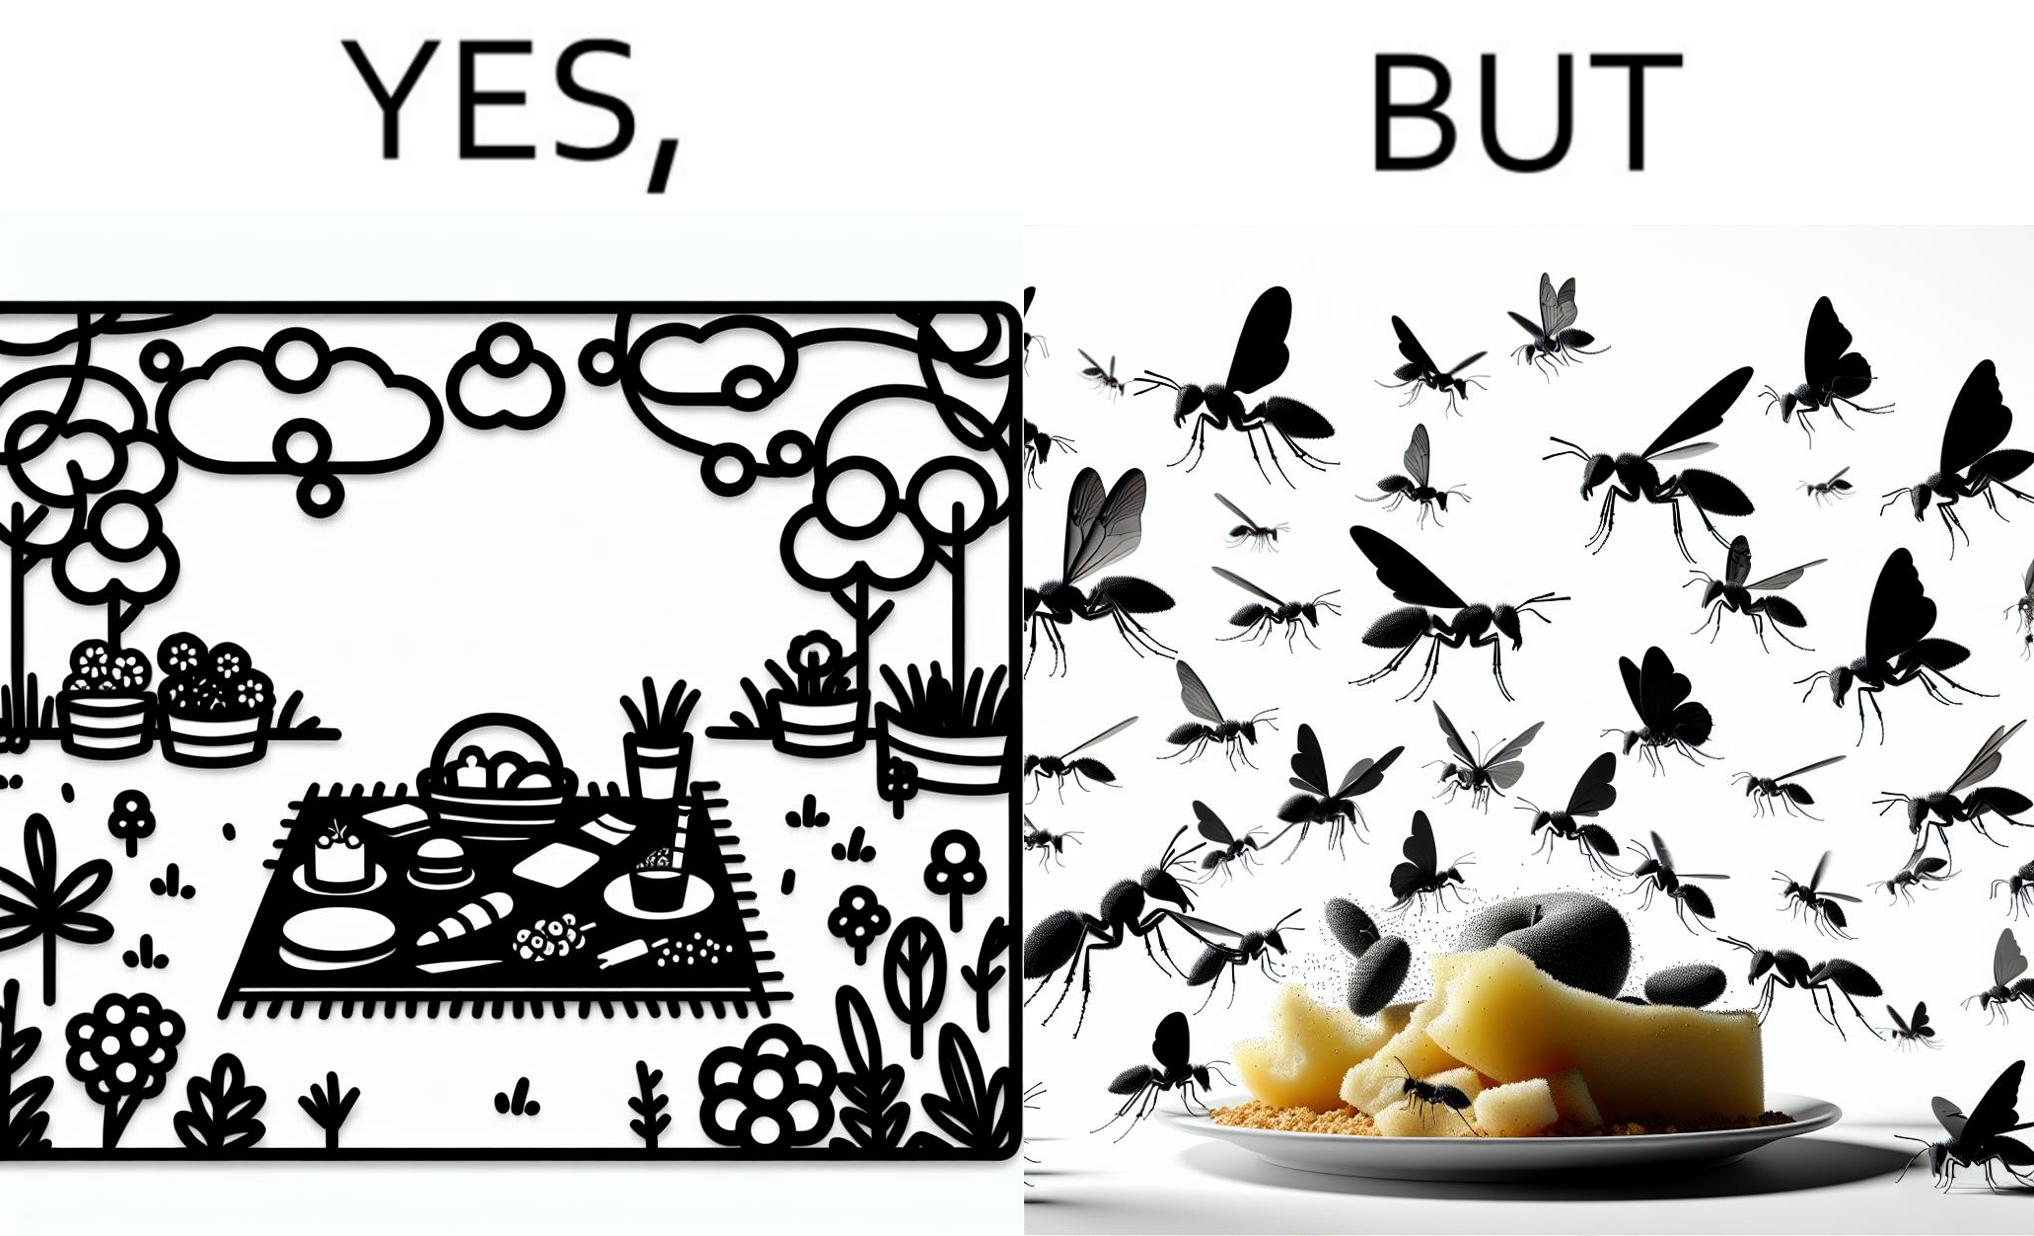Describe the satirical element in this image. The Picture shows that although we enjoy food in garden but there are some consequences of eating food in garden. Many bugs and bees are attracted towards our food and make our food sometimes non-eatable. 